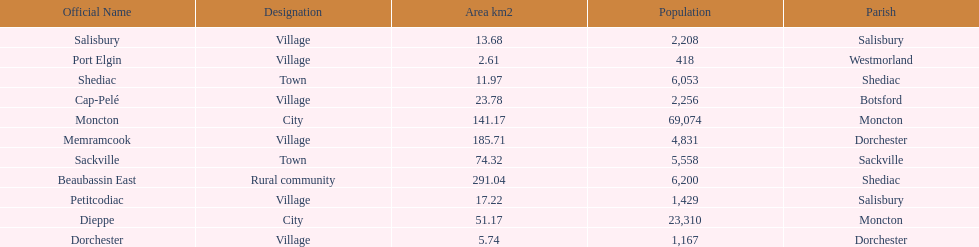Which city has the least area Port Elgin. 